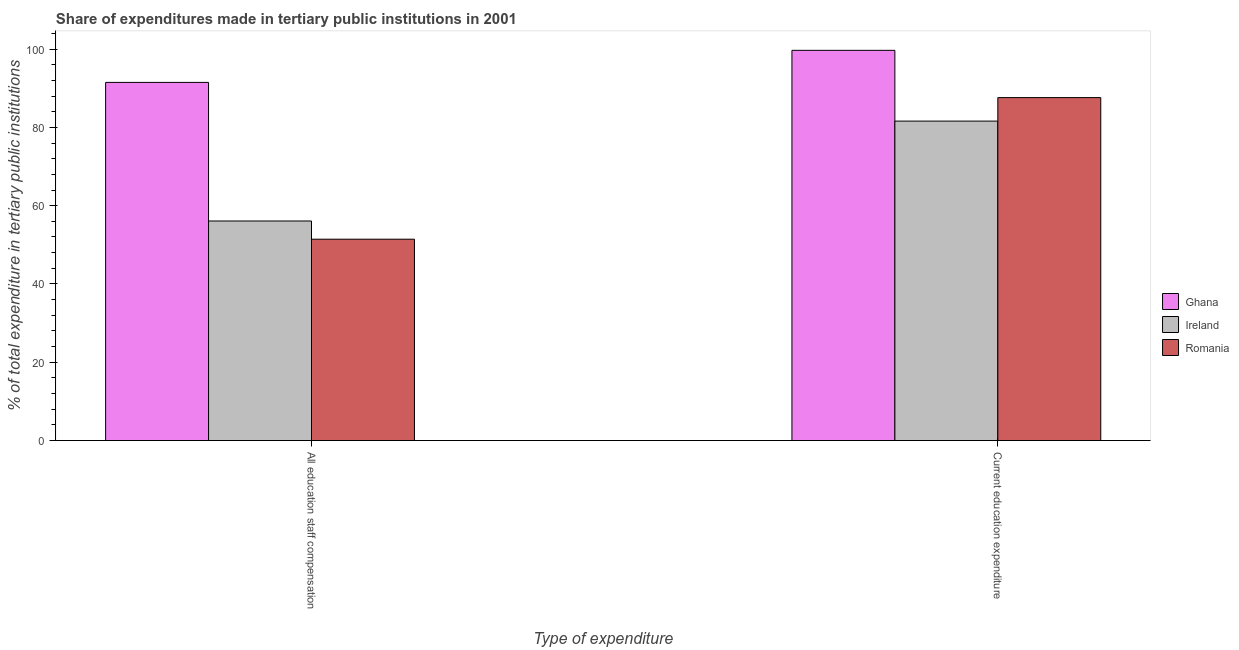How many different coloured bars are there?
Your answer should be compact. 3. Are the number of bars per tick equal to the number of legend labels?
Your response must be concise. Yes. Are the number of bars on each tick of the X-axis equal?
Your answer should be very brief. Yes. How many bars are there on the 1st tick from the left?
Offer a very short reply. 3. How many bars are there on the 1st tick from the right?
Ensure brevity in your answer.  3. What is the label of the 1st group of bars from the left?
Give a very brief answer. All education staff compensation. What is the expenditure in staff compensation in Ghana?
Your answer should be very brief. 91.48. Across all countries, what is the maximum expenditure in staff compensation?
Your answer should be very brief. 91.48. Across all countries, what is the minimum expenditure in education?
Your answer should be very brief. 81.6. In which country was the expenditure in staff compensation maximum?
Provide a short and direct response. Ghana. In which country was the expenditure in education minimum?
Offer a terse response. Ireland. What is the total expenditure in staff compensation in the graph?
Offer a very short reply. 199. What is the difference between the expenditure in education in Romania and that in Ghana?
Your answer should be very brief. -12.07. What is the difference between the expenditure in staff compensation in Romania and the expenditure in education in Ireland?
Keep it short and to the point. -30.16. What is the average expenditure in education per country?
Provide a short and direct response. 89.62. What is the difference between the expenditure in education and expenditure in staff compensation in Ireland?
Keep it short and to the point. 25.51. In how many countries, is the expenditure in staff compensation greater than 28 %?
Provide a succinct answer. 3. What is the ratio of the expenditure in staff compensation in Romania to that in Ireland?
Make the answer very short. 0.92. In how many countries, is the expenditure in staff compensation greater than the average expenditure in staff compensation taken over all countries?
Provide a succinct answer. 1. What does the 3rd bar from the left in All education staff compensation represents?
Offer a terse response. Romania. What does the 1st bar from the right in Current education expenditure represents?
Your answer should be compact. Romania. How many bars are there?
Provide a short and direct response. 6. How many countries are there in the graph?
Your answer should be very brief. 3. What is the difference between two consecutive major ticks on the Y-axis?
Give a very brief answer. 20. Does the graph contain any zero values?
Ensure brevity in your answer.  No. Does the graph contain grids?
Make the answer very short. No. How many legend labels are there?
Your response must be concise. 3. How are the legend labels stacked?
Ensure brevity in your answer.  Vertical. What is the title of the graph?
Keep it short and to the point. Share of expenditures made in tertiary public institutions in 2001. Does "Haiti" appear as one of the legend labels in the graph?
Your response must be concise. No. What is the label or title of the X-axis?
Your response must be concise. Type of expenditure. What is the label or title of the Y-axis?
Offer a very short reply. % of total expenditure in tertiary public institutions. What is the % of total expenditure in tertiary public institutions of Ghana in All education staff compensation?
Your response must be concise. 91.48. What is the % of total expenditure in tertiary public institutions in Ireland in All education staff compensation?
Offer a terse response. 56.08. What is the % of total expenditure in tertiary public institutions in Romania in All education staff compensation?
Offer a terse response. 51.44. What is the % of total expenditure in tertiary public institutions in Ghana in Current education expenditure?
Make the answer very short. 99.67. What is the % of total expenditure in tertiary public institutions in Ireland in Current education expenditure?
Provide a short and direct response. 81.6. What is the % of total expenditure in tertiary public institutions in Romania in Current education expenditure?
Provide a succinct answer. 87.6. Across all Type of expenditure, what is the maximum % of total expenditure in tertiary public institutions of Ghana?
Offer a very short reply. 99.67. Across all Type of expenditure, what is the maximum % of total expenditure in tertiary public institutions in Ireland?
Provide a succinct answer. 81.6. Across all Type of expenditure, what is the maximum % of total expenditure in tertiary public institutions of Romania?
Provide a succinct answer. 87.6. Across all Type of expenditure, what is the minimum % of total expenditure in tertiary public institutions of Ghana?
Ensure brevity in your answer.  91.48. Across all Type of expenditure, what is the minimum % of total expenditure in tertiary public institutions of Ireland?
Offer a terse response. 56.08. Across all Type of expenditure, what is the minimum % of total expenditure in tertiary public institutions of Romania?
Keep it short and to the point. 51.44. What is the total % of total expenditure in tertiary public institutions in Ghana in the graph?
Your response must be concise. 191.16. What is the total % of total expenditure in tertiary public institutions in Ireland in the graph?
Offer a terse response. 137.68. What is the total % of total expenditure in tertiary public institutions in Romania in the graph?
Your response must be concise. 139.03. What is the difference between the % of total expenditure in tertiary public institutions of Ghana in All education staff compensation and that in Current education expenditure?
Your answer should be very brief. -8.19. What is the difference between the % of total expenditure in tertiary public institutions of Ireland in All education staff compensation and that in Current education expenditure?
Your response must be concise. -25.51. What is the difference between the % of total expenditure in tertiary public institutions in Romania in All education staff compensation and that in Current education expenditure?
Offer a terse response. -36.16. What is the difference between the % of total expenditure in tertiary public institutions of Ghana in All education staff compensation and the % of total expenditure in tertiary public institutions of Ireland in Current education expenditure?
Offer a terse response. 9.89. What is the difference between the % of total expenditure in tertiary public institutions of Ghana in All education staff compensation and the % of total expenditure in tertiary public institutions of Romania in Current education expenditure?
Offer a very short reply. 3.89. What is the difference between the % of total expenditure in tertiary public institutions in Ireland in All education staff compensation and the % of total expenditure in tertiary public institutions in Romania in Current education expenditure?
Make the answer very short. -31.52. What is the average % of total expenditure in tertiary public institutions in Ghana per Type of expenditure?
Offer a very short reply. 95.58. What is the average % of total expenditure in tertiary public institutions in Ireland per Type of expenditure?
Give a very brief answer. 68.84. What is the average % of total expenditure in tertiary public institutions of Romania per Type of expenditure?
Ensure brevity in your answer.  69.52. What is the difference between the % of total expenditure in tertiary public institutions in Ghana and % of total expenditure in tertiary public institutions in Ireland in All education staff compensation?
Keep it short and to the point. 35.4. What is the difference between the % of total expenditure in tertiary public institutions in Ghana and % of total expenditure in tertiary public institutions in Romania in All education staff compensation?
Provide a short and direct response. 40.05. What is the difference between the % of total expenditure in tertiary public institutions in Ireland and % of total expenditure in tertiary public institutions in Romania in All education staff compensation?
Give a very brief answer. 4.65. What is the difference between the % of total expenditure in tertiary public institutions of Ghana and % of total expenditure in tertiary public institutions of Ireland in Current education expenditure?
Provide a short and direct response. 18.08. What is the difference between the % of total expenditure in tertiary public institutions of Ghana and % of total expenditure in tertiary public institutions of Romania in Current education expenditure?
Give a very brief answer. 12.07. What is the difference between the % of total expenditure in tertiary public institutions in Ireland and % of total expenditure in tertiary public institutions in Romania in Current education expenditure?
Keep it short and to the point. -6. What is the ratio of the % of total expenditure in tertiary public institutions of Ghana in All education staff compensation to that in Current education expenditure?
Make the answer very short. 0.92. What is the ratio of the % of total expenditure in tertiary public institutions in Ireland in All education staff compensation to that in Current education expenditure?
Offer a terse response. 0.69. What is the ratio of the % of total expenditure in tertiary public institutions in Romania in All education staff compensation to that in Current education expenditure?
Provide a short and direct response. 0.59. What is the difference between the highest and the second highest % of total expenditure in tertiary public institutions in Ghana?
Give a very brief answer. 8.19. What is the difference between the highest and the second highest % of total expenditure in tertiary public institutions of Ireland?
Ensure brevity in your answer.  25.51. What is the difference between the highest and the second highest % of total expenditure in tertiary public institutions in Romania?
Provide a succinct answer. 36.16. What is the difference between the highest and the lowest % of total expenditure in tertiary public institutions in Ghana?
Provide a short and direct response. 8.19. What is the difference between the highest and the lowest % of total expenditure in tertiary public institutions of Ireland?
Your response must be concise. 25.51. What is the difference between the highest and the lowest % of total expenditure in tertiary public institutions of Romania?
Make the answer very short. 36.16. 